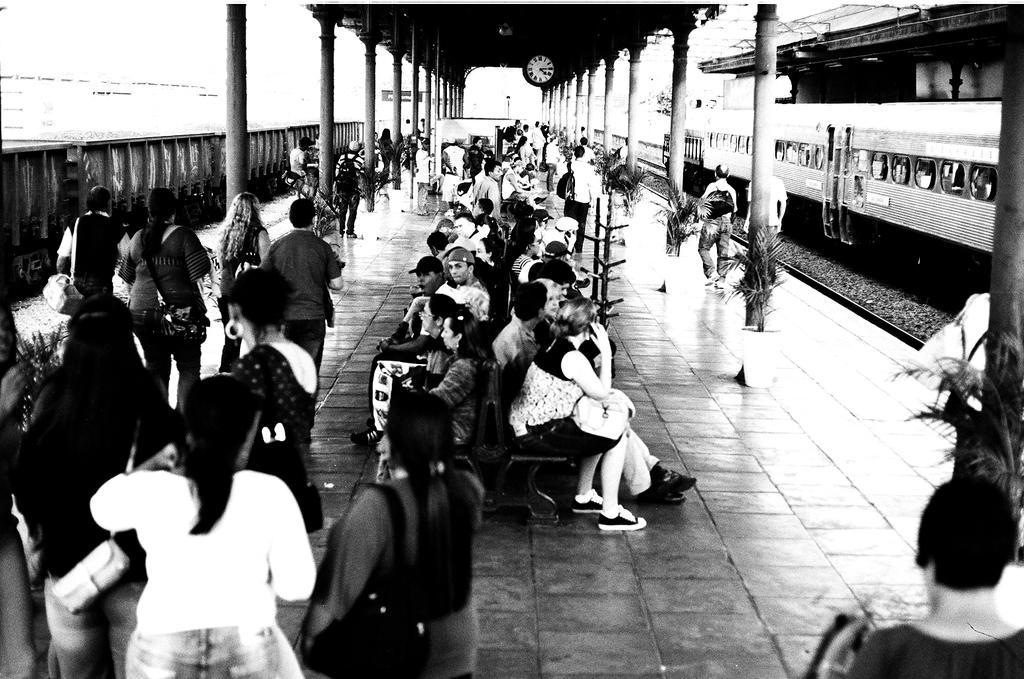Could you give a brief overview of what you see in this image? This is a black and white image. In this image we can see trains on the railway tracks, pillars, wall clock, people walking on the platform, people sitting on the benches and plants. 